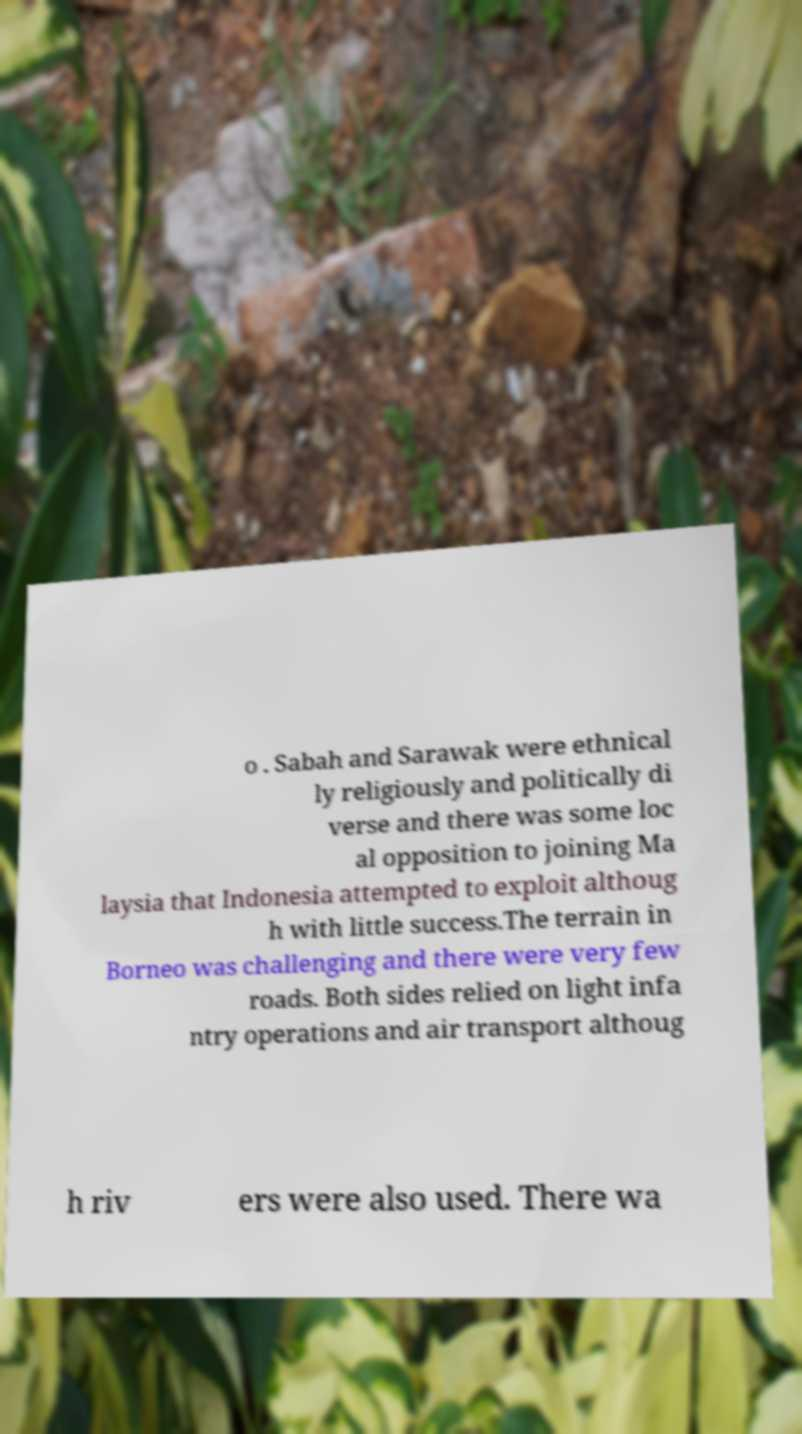Please read and relay the text visible in this image. What does it say? o . Sabah and Sarawak were ethnical ly religiously and politically di verse and there was some loc al opposition to joining Ma laysia that Indonesia attempted to exploit althoug h with little success.The terrain in Borneo was challenging and there were very few roads. Both sides relied on light infa ntry operations and air transport althoug h riv ers were also used. There wa 